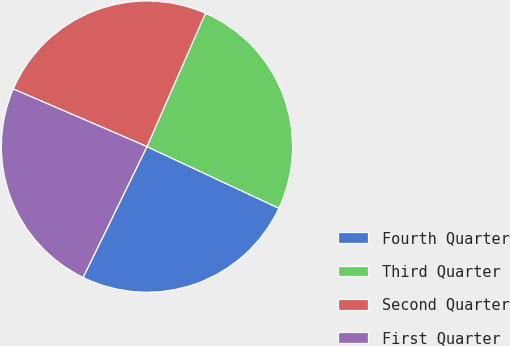Convert chart. <chart><loc_0><loc_0><loc_500><loc_500><pie_chart><fcel>Fourth Quarter<fcel>Third Quarter<fcel>Second Quarter<fcel>First Quarter<nl><fcel>25.27%<fcel>25.38%<fcel>25.1%<fcel>24.25%<nl></chart> 